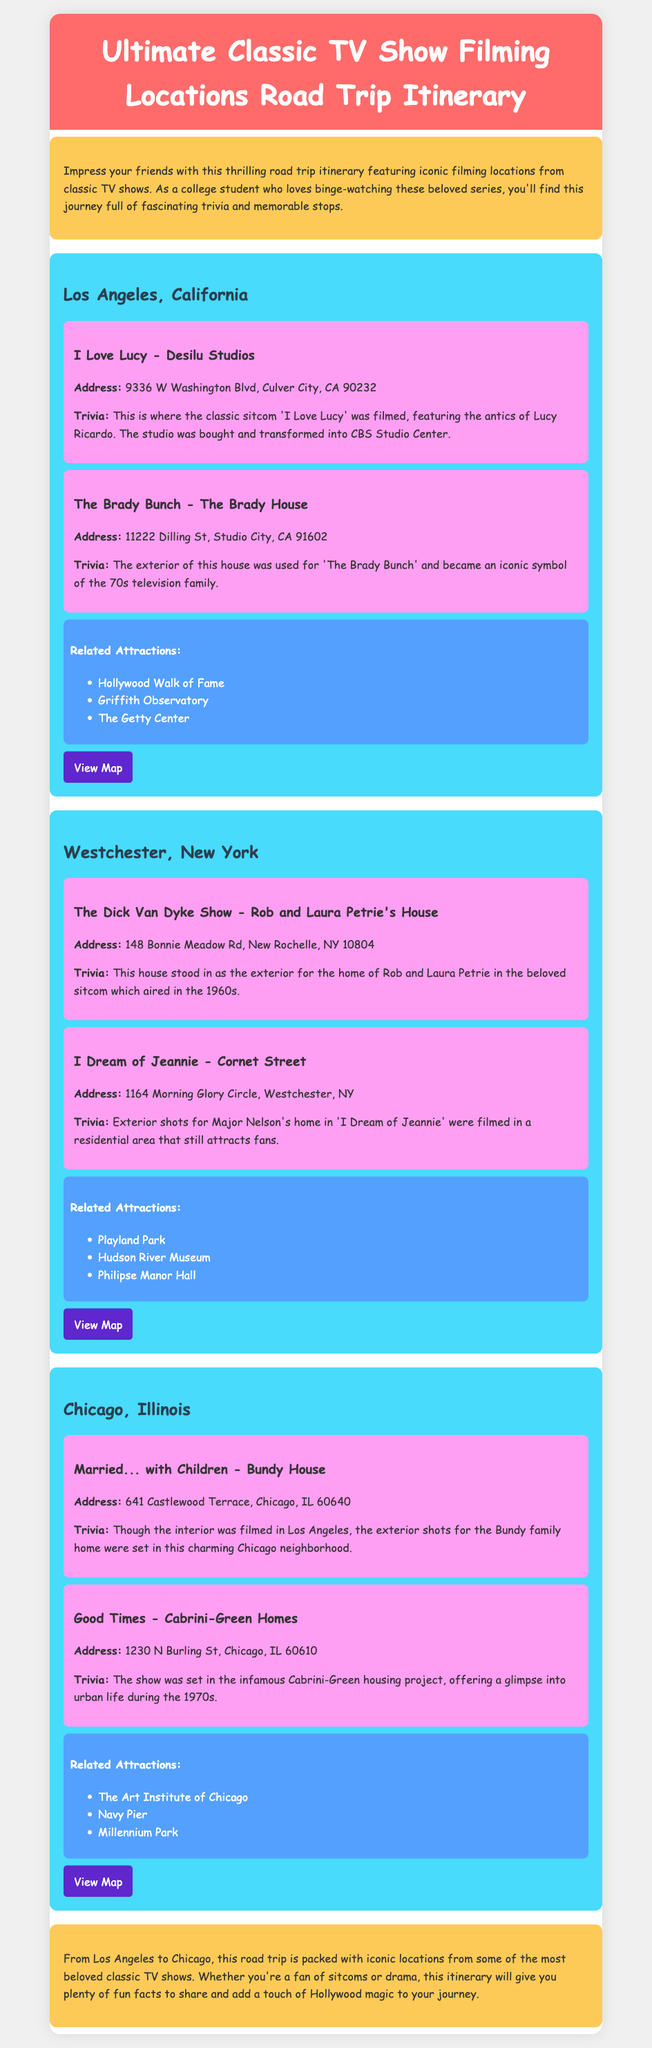what is the address of Desilu Studios? The address is specifically mentioned in the document under the filming location for 'I Love Lucy'.
Answer: 9336 W Washington Blvd, Culver City, CA 90232 what classic TV show featured the Brady House? The document explicitly states the show associated with the Brady House, which is 'The Brady Bunch'.
Answer: The Brady Bunch how many filming locations are listed in Los Angeles? The document details the number of filming locations present for Los Angeles, which are two.
Answer: Two what filming location is associated with the address 148 Bonnie Meadow Rd? This address is tied to a specific show, which is stated in the document under its corresponding filming location.
Answer: The Dick Van Dyke Show which city is associated with the Bundy House? The document reveals the city name under the address of the Bundy House filming location.
Answer: Chicago what is a related attraction listed for Westchester, New York? The document provides a list of attractions, and I can refer to one of them from that mentioned section.
Answer: Playland Park how many cities are included in the itinerary? The document summarizes the locations featured, and I can figure out how many different cities are mentioned in total.
Answer: Three which filming location was set in Cabrini-Green? The document points out a show linked with a specific address and provides essential details about it.
Answer: Good Times 